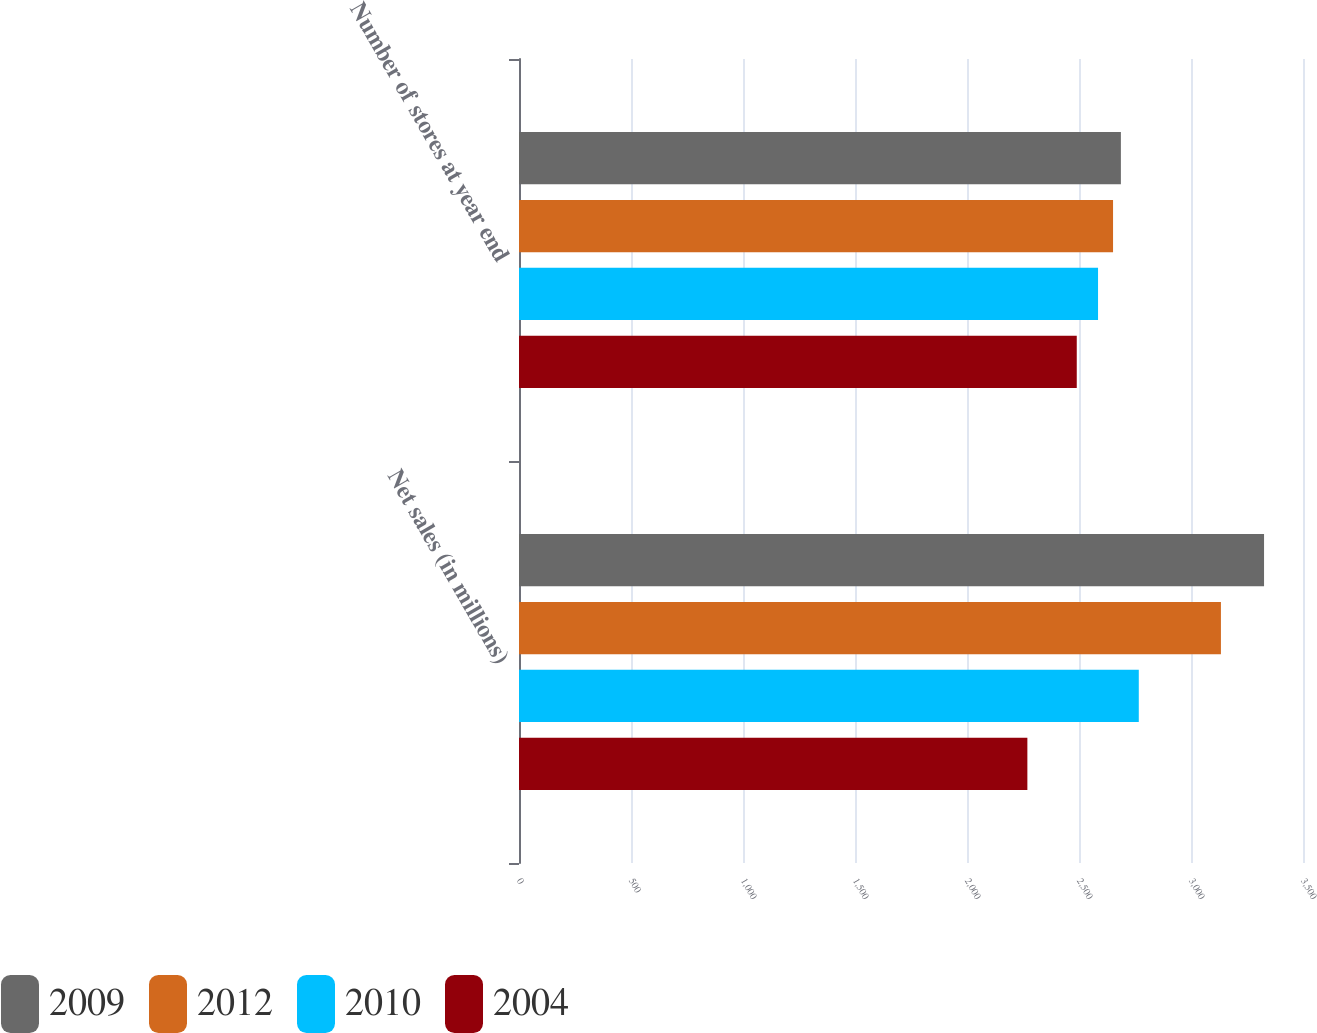Convert chart to OTSL. <chart><loc_0><loc_0><loc_500><loc_500><stacked_bar_chart><ecel><fcel>Net sales (in millions)<fcel>Number of stores at year end<nl><fcel>2009<fcel>3326.1<fcel>2687<nl><fcel>2012<fcel>3133.6<fcel>2652<nl><fcel>2010<fcel>2766.9<fcel>2585<nl><fcel>2004<fcel>2269.5<fcel>2490<nl></chart> 